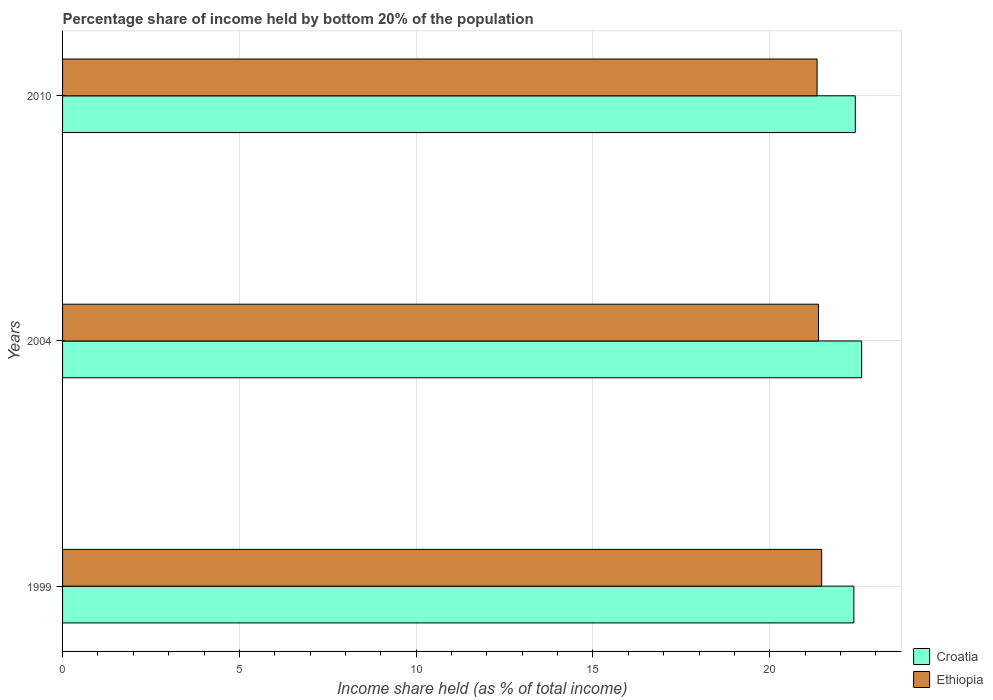How many different coloured bars are there?
Keep it short and to the point. 2. How many groups of bars are there?
Offer a terse response. 3. Are the number of bars on each tick of the Y-axis equal?
Keep it short and to the point. Yes. How many bars are there on the 3rd tick from the top?
Provide a succinct answer. 2. How many bars are there on the 3rd tick from the bottom?
Give a very brief answer. 2. What is the share of income held by bottom 20% of the population in Croatia in 2010?
Offer a terse response. 22.42. Across all years, what is the maximum share of income held by bottom 20% of the population in Ethiopia?
Give a very brief answer. 21.47. Across all years, what is the minimum share of income held by bottom 20% of the population in Ethiopia?
Your answer should be very brief. 21.34. In which year was the share of income held by bottom 20% of the population in Croatia minimum?
Offer a terse response. 1999. What is the total share of income held by bottom 20% of the population in Ethiopia in the graph?
Give a very brief answer. 64.19. What is the difference between the share of income held by bottom 20% of the population in Croatia in 2004 and that in 2010?
Give a very brief answer. 0.18. What is the difference between the share of income held by bottom 20% of the population in Croatia in 2004 and the share of income held by bottom 20% of the population in Ethiopia in 2010?
Your answer should be compact. 1.26. What is the average share of income held by bottom 20% of the population in Ethiopia per year?
Ensure brevity in your answer.  21.4. In the year 2010, what is the difference between the share of income held by bottom 20% of the population in Croatia and share of income held by bottom 20% of the population in Ethiopia?
Keep it short and to the point. 1.08. What is the ratio of the share of income held by bottom 20% of the population in Ethiopia in 1999 to that in 2004?
Offer a terse response. 1. Is the share of income held by bottom 20% of the population in Ethiopia in 1999 less than that in 2010?
Ensure brevity in your answer.  No. Is the difference between the share of income held by bottom 20% of the population in Croatia in 1999 and 2010 greater than the difference between the share of income held by bottom 20% of the population in Ethiopia in 1999 and 2010?
Your answer should be compact. No. What is the difference between the highest and the second highest share of income held by bottom 20% of the population in Croatia?
Offer a very short reply. 0.18. What is the difference between the highest and the lowest share of income held by bottom 20% of the population in Croatia?
Your answer should be compact. 0.22. In how many years, is the share of income held by bottom 20% of the population in Croatia greater than the average share of income held by bottom 20% of the population in Croatia taken over all years?
Make the answer very short. 1. What does the 2nd bar from the top in 1999 represents?
Make the answer very short. Croatia. What does the 2nd bar from the bottom in 2004 represents?
Ensure brevity in your answer.  Ethiopia. Are all the bars in the graph horizontal?
Your response must be concise. Yes. What is the difference between two consecutive major ticks on the X-axis?
Offer a very short reply. 5. Does the graph contain any zero values?
Make the answer very short. No. What is the title of the graph?
Provide a short and direct response. Percentage share of income held by bottom 20% of the population. What is the label or title of the X-axis?
Make the answer very short. Income share held (as % of total income). What is the label or title of the Y-axis?
Offer a terse response. Years. What is the Income share held (as % of total income) in Croatia in 1999?
Your answer should be very brief. 22.38. What is the Income share held (as % of total income) of Ethiopia in 1999?
Your answer should be very brief. 21.47. What is the Income share held (as % of total income) of Croatia in 2004?
Your response must be concise. 22.6. What is the Income share held (as % of total income) of Ethiopia in 2004?
Offer a very short reply. 21.38. What is the Income share held (as % of total income) of Croatia in 2010?
Make the answer very short. 22.42. What is the Income share held (as % of total income) of Ethiopia in 2010?
Offer a terse response. 21.34. Across all years, what is the maximum Income share held (as % of total income) in Croatia?
Keep it short and to the point. 22.6. Across all years, what is the maximum Income share held (as % of total income) of Ethiopia?
Your answer should be compact. 21.47. Across all years, what is the minimum Income share held (as % of total income) in Croatia?
Make the answer very short. 22.38. Across all years, what is the minimum Income share held (as % of total income) in Ethiopia?
Keep it short and to the point. 21.34. What is the total Income share held (as % of total income) in Croatia in the graph?
Provide a succinct answer. 67.4. What is the total Income share held (as % of total income) of Ethiopia in the graph?
Your answer should be compact. 64.19. What is the difference between the Income share held (as % of total income) in Croatia in 1999 and that in 2004?
Make the answer very short. -0.22. What is the difference between the Income share held (as % of total income) in Ethiopia in 1999 and that in 2004?
Provide a short and direct response. 0.09. What is the difference between the Income share held (as % of total income) in Croatia in 1999 and that in 2010?
Keep it short and to the point. -0.04. What is the difference between the Income share held (as % of total income) in Ethiopia in 1999 and that in 2010?
Provide a succinct answer. 0.13. What is the difference between the Income share held (as % of total income) of Croatia in 2004 and that in 2010?
Offer a very short reply. 0.18. What is the difference between the Income share held (as % of total income) of Croatia in 1999 and the Income share held (as % of total income) of Ethiopia in 2010?
Offer a terse response. 1.04. What is the difference between the Income share held (as % of total income) of Croatia in 2004 and the Income share held (as % of total income) of Ethiopia in 2010?
Your answer should be very brief. 1.26. What is the average Income share held (as % of total income) in Croatia per year?
Keep it short and to the point. 22.47. What is the average Income share held (as % of total income) in Ethiopia per year?
Ensure brevity in your answer.  21.4. In the year 1999, what is the difference between the Income share held (as % of total income) in Croatia and Income share held (as % of total income) in Ethiopia?
Your answer should be very brief. 0.91. In the year 2004, what is the difference between the Income share held (as % of total income) of Croatia and Income share held (as % of total income) of Ethiopia?
Offer a very short reply. 1.22. What is the ratio of the Income share held (as % of total income) of Croatia in 1999 to that in 2004?
Provide a short and direct response. 0.99. What is the ratio of the Income share held (as % of total income) in Ethiopia in 1999 to that in 2010?
Offer a very short reply. 1.01. What is the ratio of the Income share held (as % of total income) of Croatia in 2004 to that in 2010?
Your answer should be very brief. 1.01. What is the difference between the highest and the second highest Income share held (as % of total income) in Croatia?
Offer a terse response. 0.18. What is the difference between the highest and the second highest Income share held (as % of total income) in Ethiopia?
Provide a succinct answer. 0.09. What is the difference between the highest and the lowest Income share held (as % of total income) of Croatia?
Offer a very short reply. 0.22. What is the difference between the highest and the lowest Income share held (as % of total income) in Ethiopia?
Give a very brief answer. 0.13. 